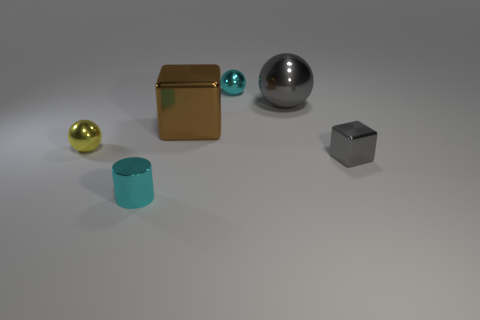Subtract all big balls. How many balls are left? 2 Add 1 tiny purple rubber cylinders. How many objects exist? 7 Subtract all cyan spheres. How many spheres are left? 2 Add 5 yellow objects. How many yellow objects exist? 6 Subtract 1 cyan balls. How many objects are left? 5 Subtract all blocks. How many objects are left? 4 Subtract all yellow cubes. Subtract all blue spheres. How many cubes are left? 2 Subtract all tiny brown cylinders. Subtract all gray shiny things. How many objects are left? 4 Add 6 big metal balls. How many big metal balls are left? 7 